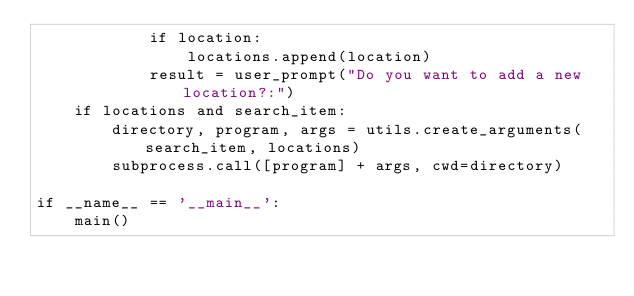<code> <loc_0><loc_0><loc_500><loc_500><_Python_>			if location: 
				locations.append(location)
			result = user_prompt("Do you want to add a new location?:")
	if locations and search_item:
		directory, program, args = utils.create_arguments(search_item, locations)
		subprocess.call([program] + args, cwd=directory)

if __name__ == '__main__':
	main()</code> 